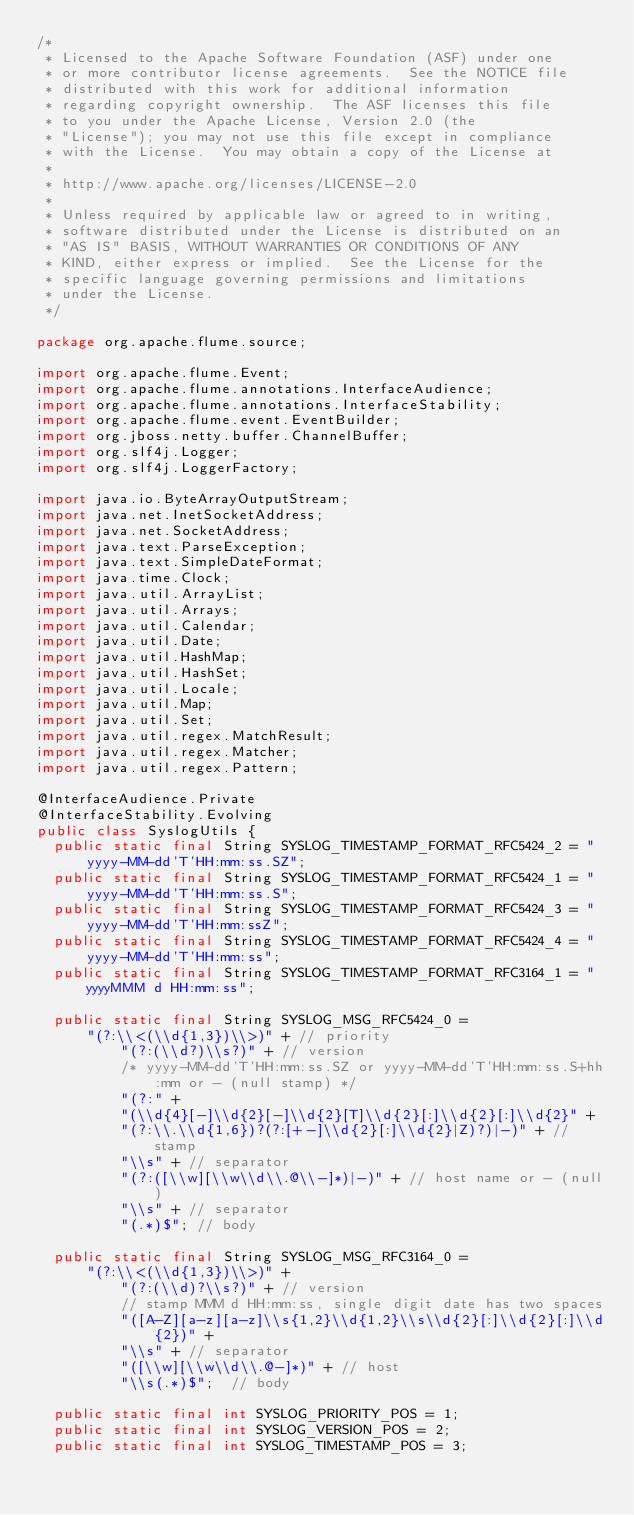Convert code to text. <code><loc_0><loc_0><loc_500><loc_500><_Java_>/*
 * Licensed to the Apache Software Foundation (ASF) under one
 * or more contributor license agreements.  See the NOTICE file
 * distributed with this work for additional information
 * regarding copyright ownership.  The ASF licenses this file
 * to you under the Apache License, Version 2.0 (the
 * "License"); you may not use this file except in compliance
 * with the License.  You may obtain a copy of the License at
 *
 * http://www.apache.org/licenses/LICENSE-2.0
 *
 * Unless required by applicable law or agreed to in writing,
 * software distributed under the License is distributed on an
 * "AS IS" BASIS, WITHOUT WARRANTIES OR CONDITIONS OF ANY
 * KIND, either express or implied.  See the License for the
 * specific language governing permissions and limitations
 * under the License.
 */

package org.apache.flume.source;

import org.apache.flume.Event;
import org.apache.flume.annotations.InterfaceAudience;
import org.apache.flume.annotations.InterfaceStability;
import org.apache.flume.event.EventBuilder;
import org.jboss.netty.buffer.ChannelBuffer;
import org.slf4j.Logger;
import org.slf4j.LoggerFactory;

import java.io.ByteArrayOutputStream;
import java.net.InetSocketAddress;
import java.net.SocketAddress;
import java.text.ParseException;
import java.text.SimpleDateFormat;
import java.time.Clock;
import java.util.ArrayList;
import java.util.Arrays;
import java.util.Calendar;
import java.util.Date;
import java.util.HashMap;
import java.util.HashSet;
import java.util.Locale;
import java.util.Map;
import java.util.Set;
import java.util.regex.MatchResult;
import java.util.regex.Matcher;
import java.util.regex.Pattern;

@InterfaceAudience.Private
@InterfaceStability.Evolving
public class SyslogUtils {
  public static final String SYSLOG_TIMESTAMP_FORMAT_RFC5424_2 = "yyyy-MM-dd'T'HH:mm:ss.SZ";
  public static final String SYSLOG_TIMESTAMP_FORMAT_RFC5424_1 = "yyyy-MM-dd'T'HH:mm:ss.S";
  public static final String SYSLOG_TIMESTAMP_FORMAT_RFC5424_3 = "yyyy-MM-dd'T'HH:mm:ssZ";
  public static final String SYSLOG_TIMESTAMP_FORMAT_RFC5424_4 = "yyyy-MM-dd'T'HH:mm:ss";
  public static final String SYSLOG_TIMESTAMP_FORMAT_RFC3164_1 = "yyyyMMM d HH:mm:ss";

  public static final String SYSLOG_MSG_RFC5424_0 =
      "(?:\\<(\\d{1,3})\\>)" + // priority
          "(?:(\\d?)\\s?)" + // version
          /* yyyy-MM-dd'T'HH:mm:ss.SZ or yyyy-MM-dd'T'HH:mm:ss.S+hh:mm or - (null stamp) */
          "(?:" +
          "(\\d{4}[-]\\d{2}[-]\\d{2}[T]\\d{2}[:]\\d{2}[:]\\d{2}" +
          "(?:\\.\\d{1,6})?(?:[+-]\\d{2}[:]\\d{2}|Z)?)|-)" + // stamp
          "\\s" + // separator
          "(?:([\\w][\\w\\d\\.@\\-]*)|-)" + // host name or - (null)
          "\\s" + // separator
          "(.*)$"; // body

  public static final String SYSLOG_MSG_RFC3164_0 =
      "(?:\\<(\\d{1,3})\\>)" +
          "(?:(\\d)?\\s?)" + // version
          // stamp MMM d HH:mm:ss, single digit date has two spaces
          "([A-Z][a-z][a-z]\\s{1,2}\\d{1,2}\\s\\d{2}[:]\\d{2}[:]\\d{2})" +
          "\\s" + // separator
          "([\\w][\\w\\d\\.@-]*)" + // host
          "\\s(.*)$";  // body

  public static final int SYSLOG_PRIORITY_POS = 1;
  public static final int SYSLOG_VERSION_POS = 2;
  public static final int SYSLOG_TIMESTAMP_POS = 3;</code> 